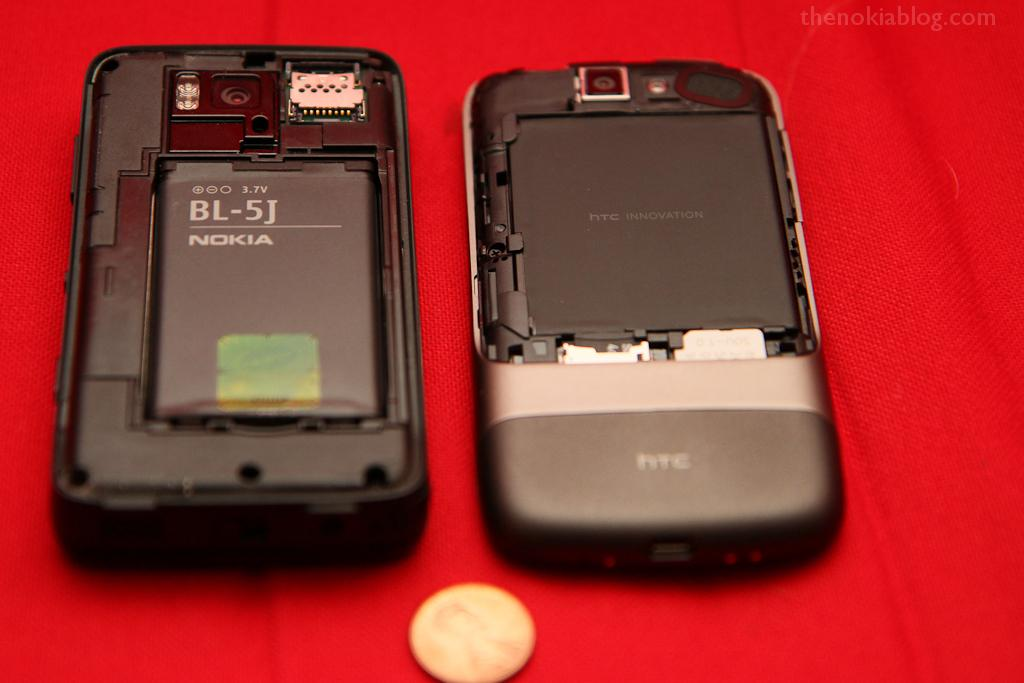<image>
Create a compact narrative representing the image presented. Two cellphone batteries are visible, on the left is a Nokia BL-5J. 